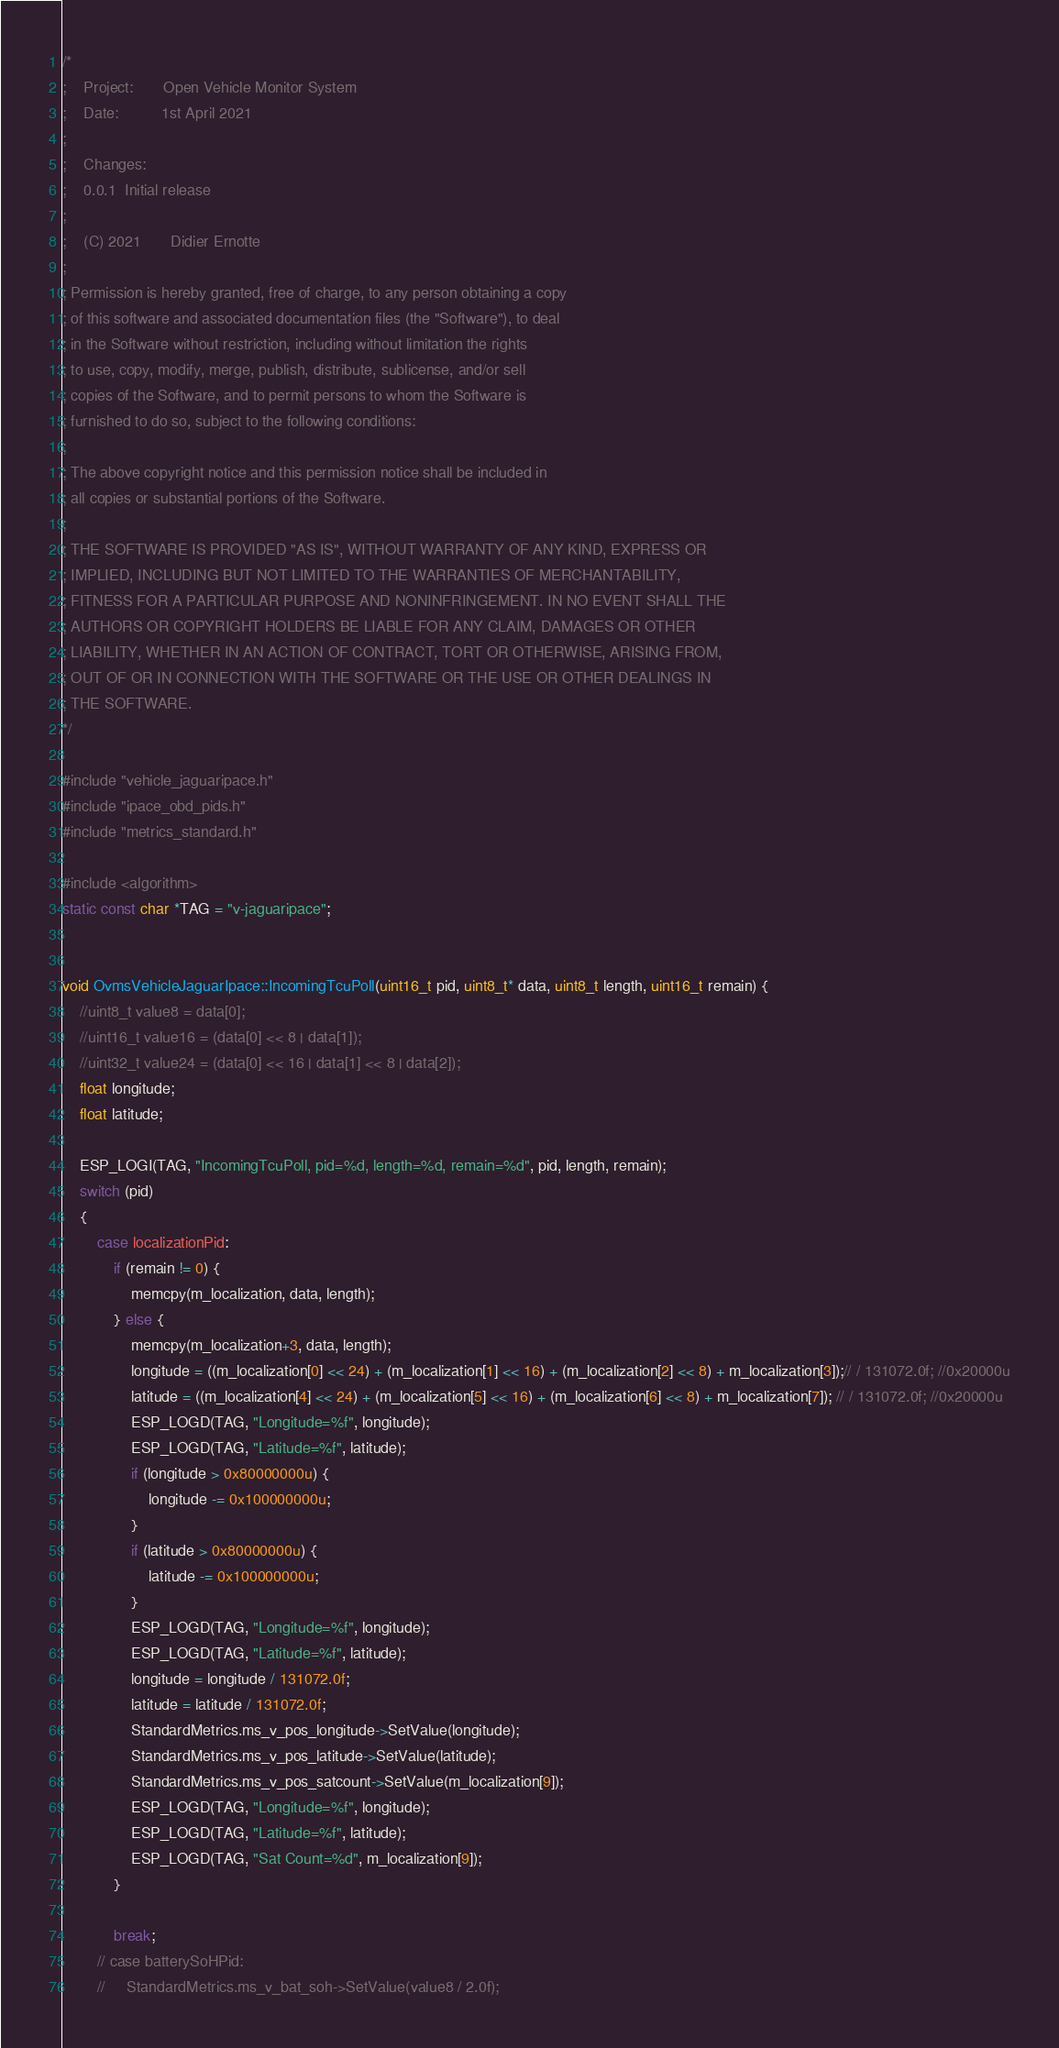<code> <loc_0><loc_0><loc_500><loc_500><_C++_>/*
;    Project:       Open Vehicle Monitor System
;    Date:          1st April 2021
;
;    Changes:
;    0.0.1  Initial release
;
;    (C) 2021       Didier Ernotte
;
; Permission is hereby granted, free of charge, to any person obtaining a copy
; of this software and associated documentation files (the "Software"), to deal
; in the Software without restriction, including without limitation the rights
; to use, copy, modify, merge, publish, distribute, sublicense, and/or sell
; copies of the Software, and to permit persons to whom the Software is
; furnished to do so, subject to the following conditions:
;
; The above copyright notice and this permission notice shall be included in
; all copies or substantial portions of the Software.
;
; THE SOFTWARE IS PROVIDED "AS IS", WITHOUT WARRANTY OF ANY KIND, EXPRESS OR
; IMPLIED, INCLUDING BUT NOT LIMITED TO THE WARRANTIES OF MERCHANTABILITY,
; FITNESS FOR A PARTICULAR PURPOSE AND NONINFRINGEMENT. IN NO EVENT SHALL THE
; AUTHORS OR COPYRIGHT HOLDERS BE LIABLE FOR ANY CLAIM, DAMAGES OR OTHER
; LIABILITY, WHETHER IN AN ACTION OF CONTRACT, TORT OR OTHERWISE, ARISING FROM,
; OUT OF OR IN CONNECTION WITH THE SOFTWARE OR THE USE OR OTHER DEALINGS IN
; THE SOFTWARE.
*/

#include "vehicle_jaguaripace.h"
#include "ipace_obd_pids.h"
#include "metrics_standard.h"

#include <algorithm>
static const char *TAG = "v-jaguaripace";


void OvmsVehicleJaguarIpace::IncomingTcuPoll(uint16_t pid, uint8_t* data, uint8_t length, uint16_t remain) {
    //uint8_t value8 = data[0];
    //uint16_t value16 = (data[0] << 8 | data[1]);
    //uint32_t value24 = (data[0] << 16 | data[1] << 8 | data[2]);
    float longitude;
    float latitude;

    ESP_LOGI(TAG, "IncomingTcuPoll, pid=%d, length=%d, remain=%d", pid, length, remain);
    switch (pid)
    {
        case localizationPid:
            if (remain != 0) {
                memcpy(m_localization, data, length);
            } else {
                memcpy(m_localization+3, data, length);
                longitude = ((m_localization[0] << 24) + (m_localization[1] << 16) + (m_localization[2] << 8) + m_localization[3]);// / 131072.0f; //0x20000u
                latitude = ((m_localization[4] << 24) + (m_localization[5] << 16) + (m_localization[6] << 8) + m_localization[7]); // / 131072.0f; //0x20000u
                ESP_LOGD(TAG, "Longitude=%f", longitude);
                ESP_LOGD(TAG, "Latitude=%f", latitude);
                if (longitude > 0x80000000u) {
                    longitude -= 0x100000000u;
                }
                if (latitude > 0x80000000u) {
                    latitude -= 0x100000000u;
                }
                ESP_LOGD(TAG, "Longitude=%f", longitude);
                ESP_LOGD(TAG, "Latitude=%f", latitude);
                longitude = longitude / 131072.0f;
                latitude = latitude / 131072.0f;
                StandardMetrics.ms_v_pos_longitude->SetValue(longitude);
                StandardMetrics.ms_v_pos_latitude->SetValue(latitude);
                StandardMetrics.ms_v_pos_satcount->SetValue(m_localization[9]);
                ESP_LOGD(TAG, "Longitude=%f", longitude);
                ESP_LOGD(TAG, "Latitude=%f", latitude);
                ESP_LOGD(TAG, "Sat Count=%d", m_localization[9]);
            }
            
            break;
        // case batterySoHPid:
        //     StandardMetrics.ms_v_bat_soh->SetValue(value8 / 2.0f);</code> 